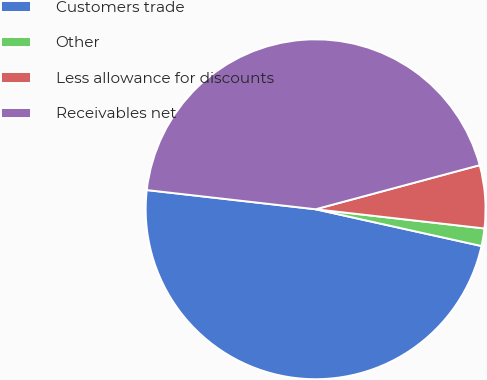Convert chart. <chart><loc_0><loc_0><loc_500><loc_500><pie_chart><fcel>Customers trade<fcel>Other<fcel>Less allowance for discounts<fcel>Receivables net<nl><fcel>48.33%<fcel>1.67%<fcel>5.98%<fcel>44.02%<nl></chart> 